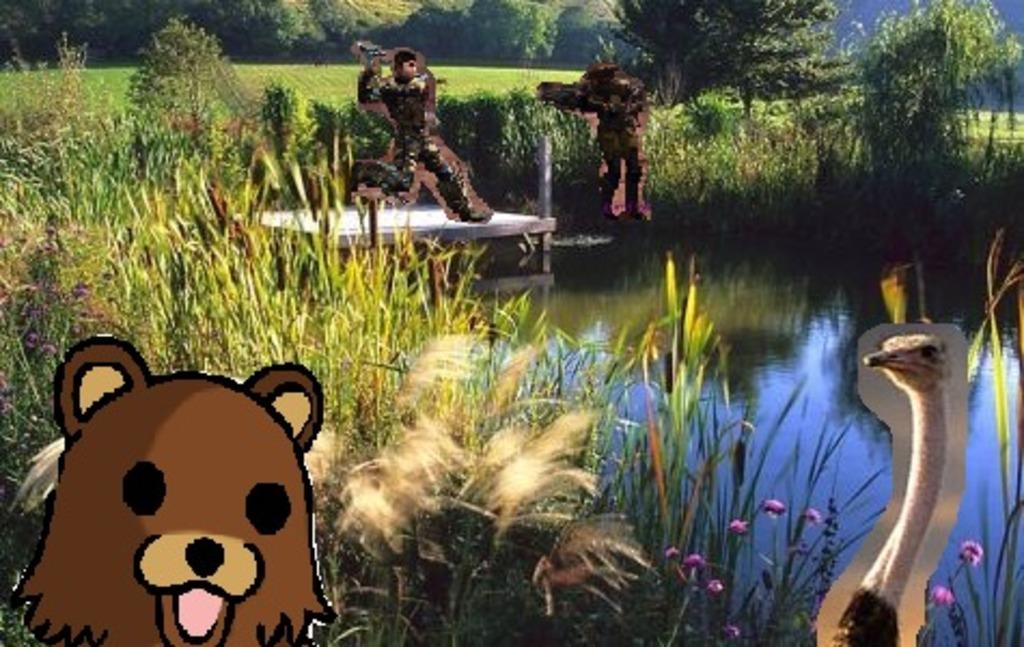What type of plants can be seen in the image? There are flowers in the image. What is the primary element visible in the image? Water is visible in the image. What type of surface is present in the image? There is a wooden platform in the image. What type of vegetation is present on the ground in the image? There is grass in the image. What type of images are present in the image? There are animated images in the image. What can be seen in the background of the image? There are trees in the background of the image. What type of celery is being used as a prop in the image? There is no celery present in the image. Can you tell me the name of the father of the person in the image? There is no person in the image, so it is not possible to determine the name of their father. 